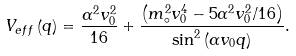Convert formula to latex. <formula><loc_0><loc_0><loc_500><loc_500>V _ { e f f } \left ( q \right ) = \frac { \alpha ^ { 2 } v _ { 0 } ^ { 2 } } { 1 6 } + \frac { \left ( m _ { \circ } ^ { 2 } v _ { 0 } ^ { 4 } - 5 \alpha ^ { 2 } v _ { 0 } ^ { 2 } / 1 6 \right ) } { \sin ^ { 2 } \left ( \alpha v _ { 0 } q \right ) } .</formula> 